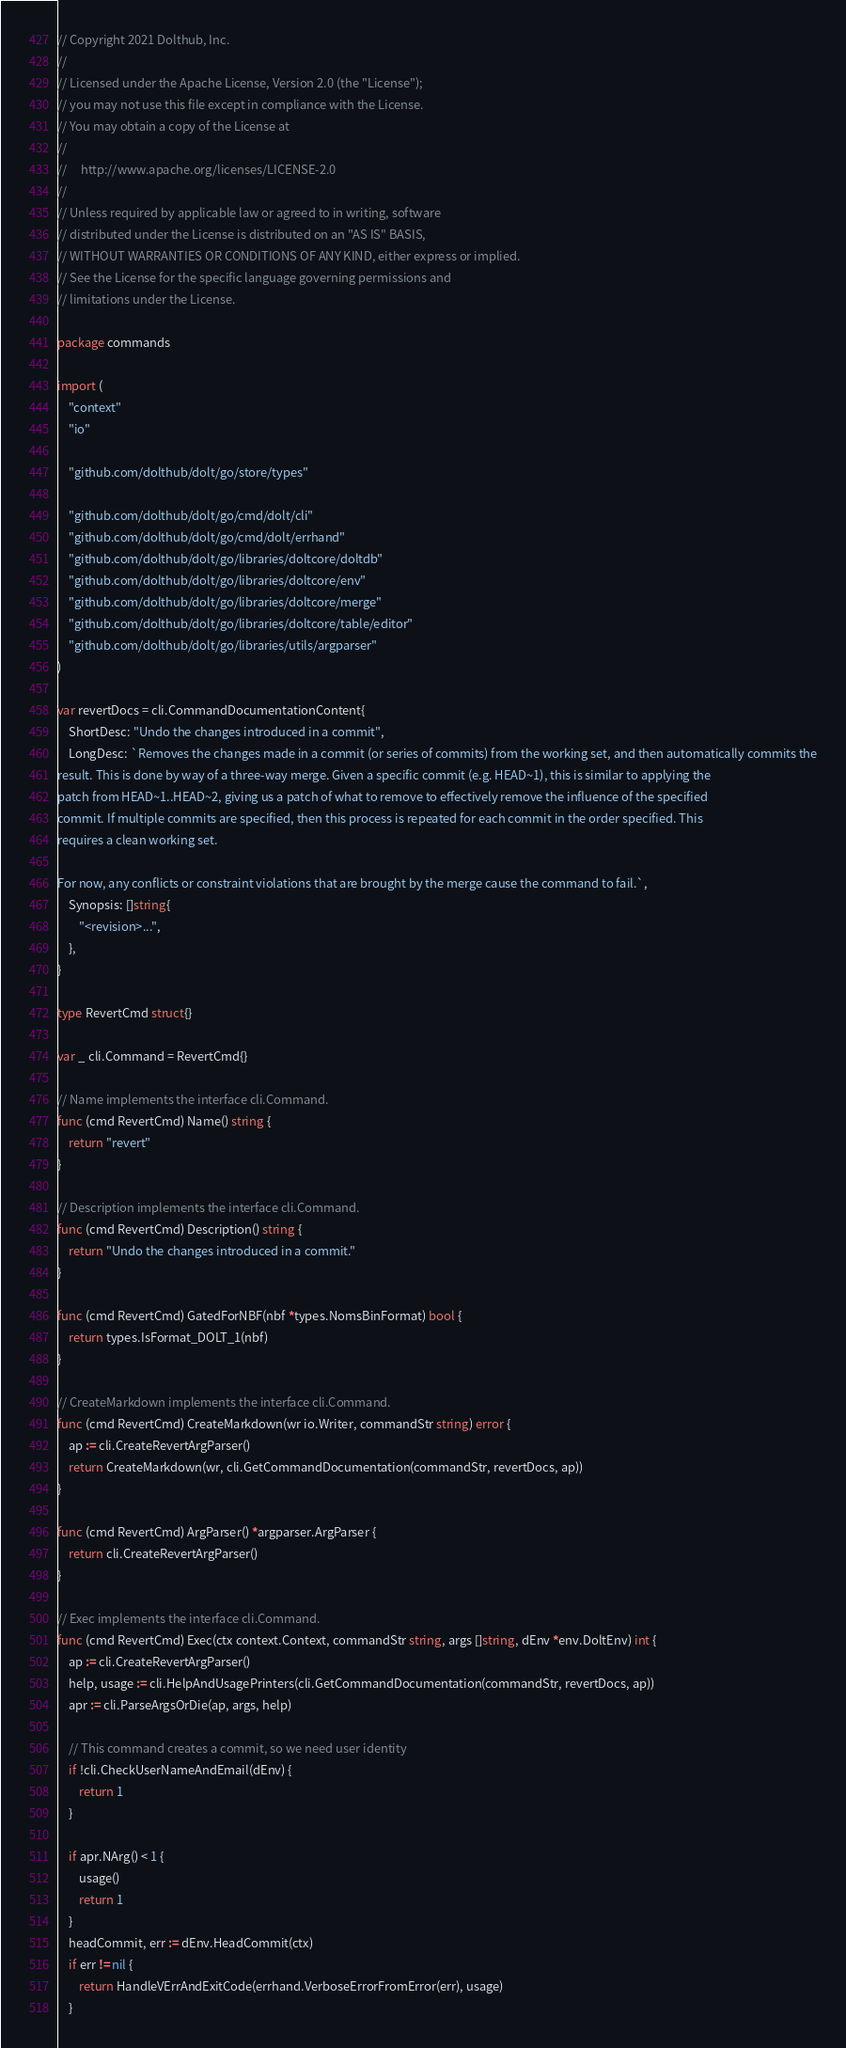Convert code to text. <code><loc_0><loc_0><loc_500><loc_500><_Go_>// Copyright 2021 Dolthub, Inc.
//
// Licensed under the Apache License, Version 2.0 (the "License");
// you may not use this file except in compliance with the License.
// You may obtain a copy of the License at
//
//     http://www.apache.org/licenses/LICENSE-2.0
//
// Unless required by applicable law or agreed to in writing, software
// distributed under the License is distributed on an "AS IS" BASIS,
// WITHOUT WARRANTIES OR CONDITIONS OF ANY KIND, either express or implied.
// See the License for the specific language governing permissions and
// limitations under the License.

package commands

import (
	"context"
	"io"

	"github.com/dolthub/dolt/go/store/types"

	"github.com/dolthub/dolt/go/cmd/dolt/cli"
	"github.com/dolthub/dolt/go/cmd/dolt/errhand"
	"github.com/dolthub/dolt/go/libraries/doltcore/doltdb"
	"github.com/dolthub/dolt/go/libraries/doltcore/env"
	"github.com/dolthub/dolt/go/libraries/doltcore/merge"
	"github.com/dolthub/dolt/go/libraries/doltcore/table/editor"
	"github.com/dolthub/dolt/go/libraries/utils/argparser"
)

var revertDocs = cli.CommandDocumentationContent{
	ShortDesc: "Undo the changes introduced in a commit",
	LongDesc: `Removes the changes made in a commit (or series of commits) from the working set, and then automatically commits the
result. This is done by way of a three-way merge. Given a specific commit (e.g. HEAD~1), this is similar to applying the
patch from HEAD~1..HEAD~2, giving us a patch of what to remove to effectively remove the influence of the specified
commit. If multiple commits are specified, then this process is repeated for each commit in the order specified. This
requires a clean working set.

For now, any conflicts or constraint violations that are brought by the merge cause the command to fail.`,
	Synopsis: []string{
		"<revision>...",
	},
}

type RevertCmd struct{}

var _ cli.Command = RevertCmd{}

// Name implements the interface cli.Command.
func (cmd RevertCmd) Name() string {
	return "revert"
}

// Description implements the interface cli.Command.
func (cmd RevertCmd) Description() string {
	return "Undo the changes introduced in a commit."
}

func (cmd RevertCmd) GatedForNBF(nbf *types.NomsBinFormat) bool {
	return types.IsFormat_DOLT_1(nbf)
}

// CreateMarkdown implements the interface cli.Command.
func (cmd RevertCmd) CreateMarkdown(wr io.Writer, commandStr string) error {
	ap := cli.CreateRevertArgParser()
	return CreateMarkdown(wr, cli.GetCommandDocumentation(commandStr, revertDocs, ap))
}

func (cmd RevertCmd) ArgParser() *argparser.ArgParser {
	return cli.CreateRevertArgParser()
}

// Exec implements the interface cli.Command.
func (cmd RevertCmd) Exec(ctx context.Context, commandStr string, args []string, dEnv *env.DoltEnv) int {
	ap := cli.CreateRevertArgParser()
	help, usage := cli.HelpAndUsagePrinters(cli.GetCommandDocumentation(commandStr, revertDocs, ap))
	apr := cli.ParseArgsOrDie(ap, args, help)

	// This command creates a commit, so we need user identity
	if !cli.CheckUserNameAndEmail(dEnv) {
		return 1
	}

	if apr.NArg() < 1 {
		usage()
		return 1
	}
	headCommit, err := dEnv.HeadCommit(ctx)
	if err != nil {
		return HandleVErrAndExitCode(errhand.VerboseErrorFromError(err), usage)
	}</code> 